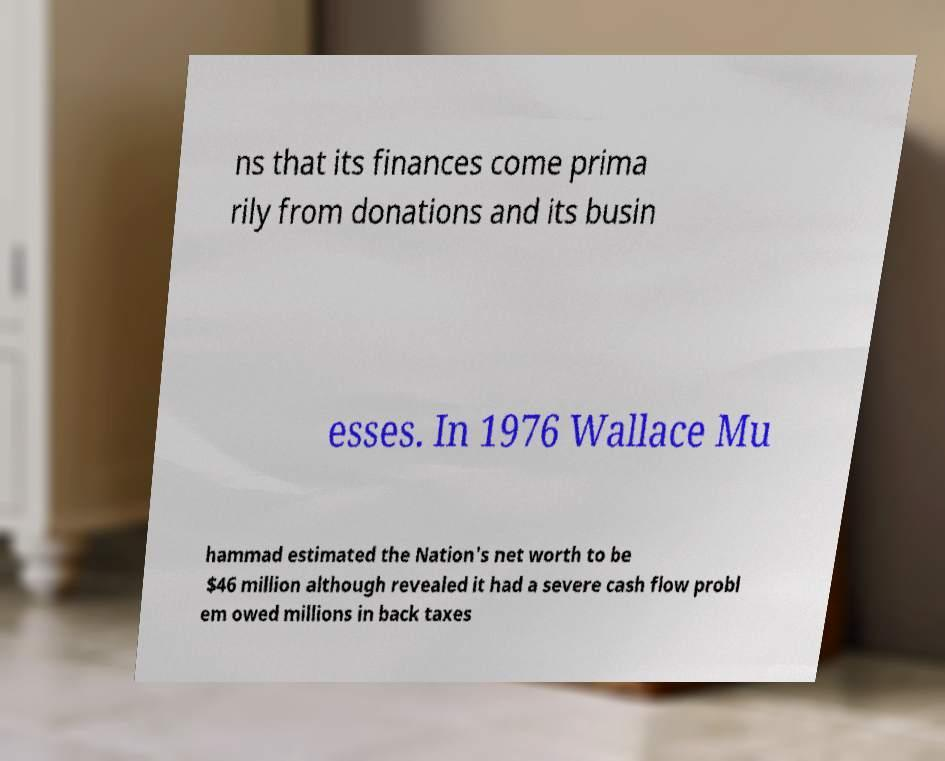There's text embedded in this image that I need extracted. Can you transcribe it verbatim? ns that its finances come prima rily from donations and its busin esses. In 1976 Wallace Mu hammad estimated the Nation's net worth to be $46 million although revealed it had a severe cash flow probl em owed millions in back taxes 